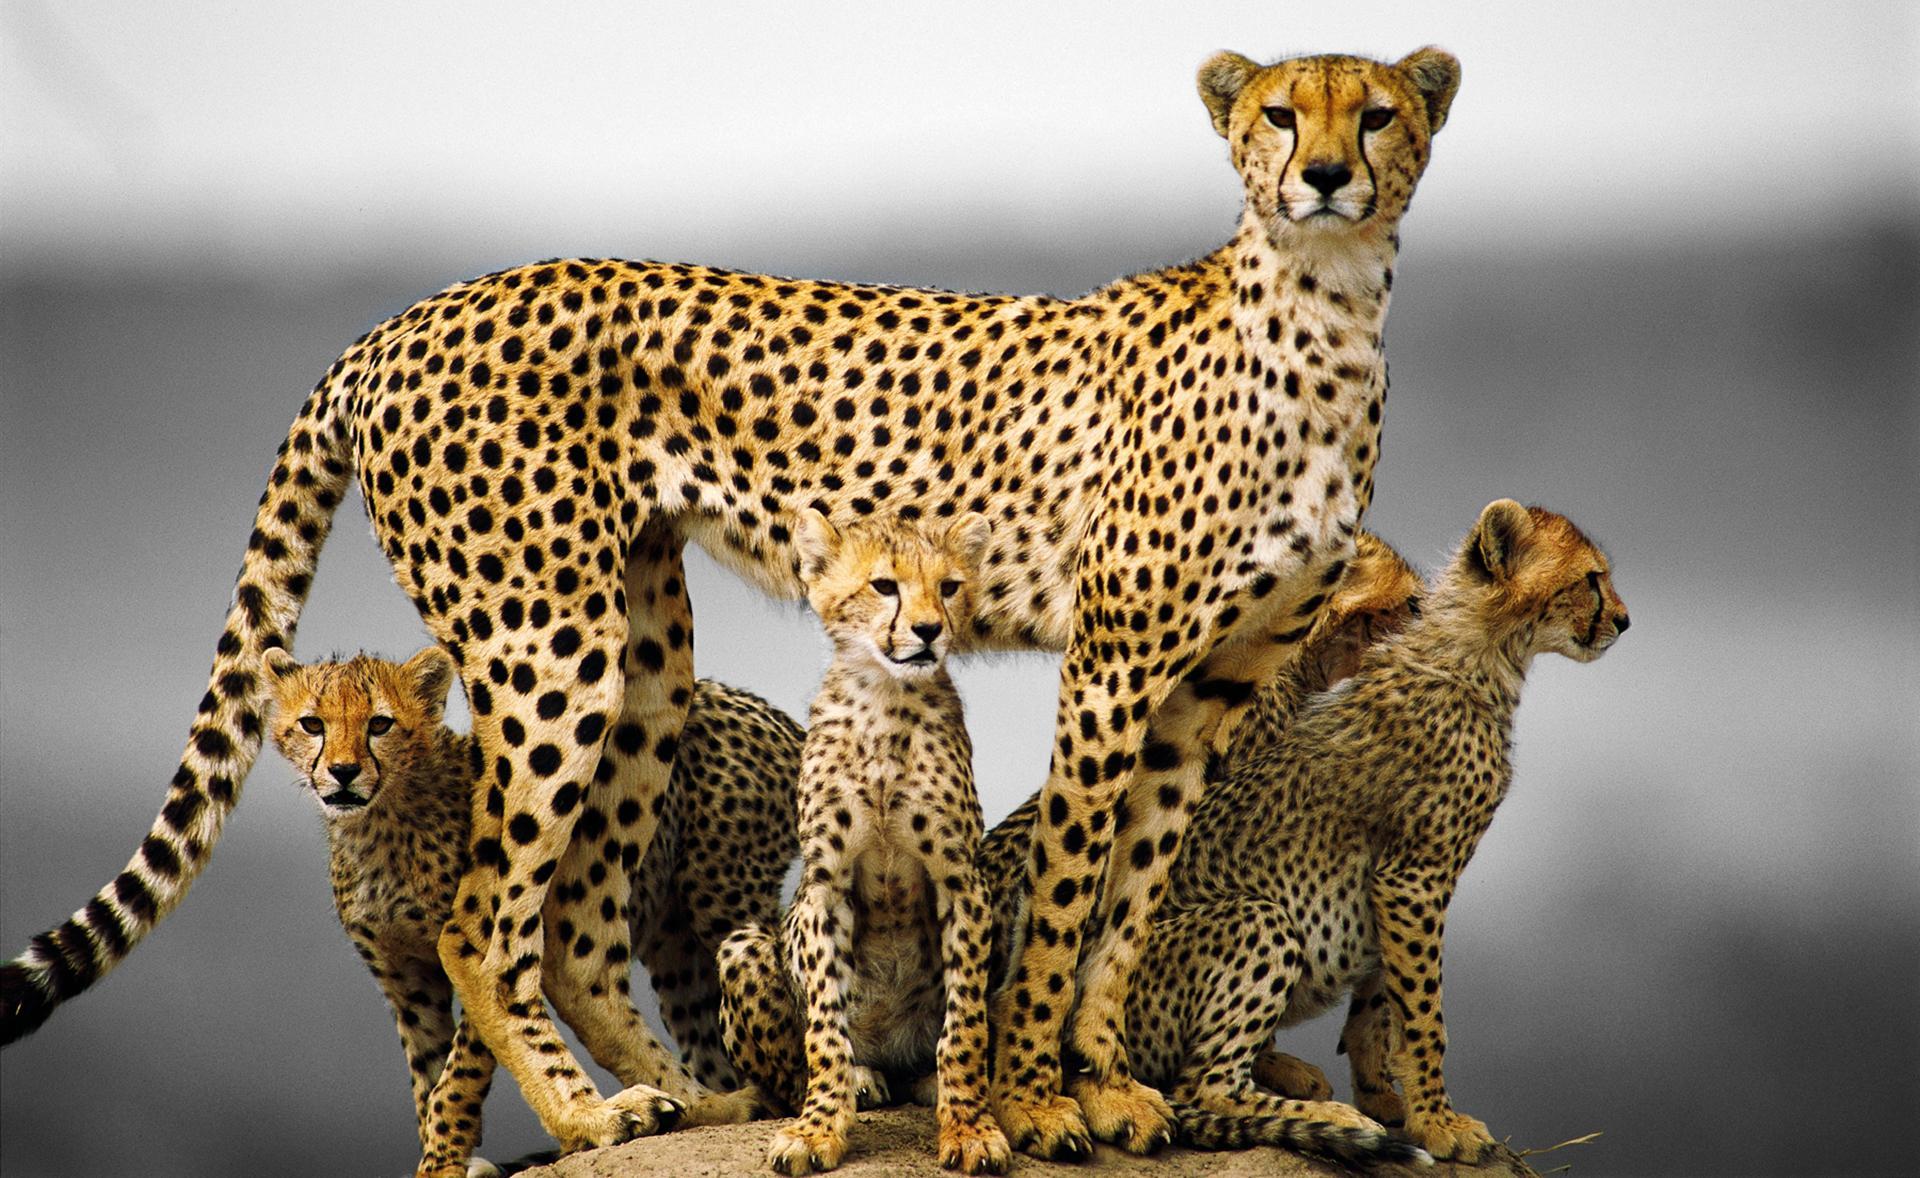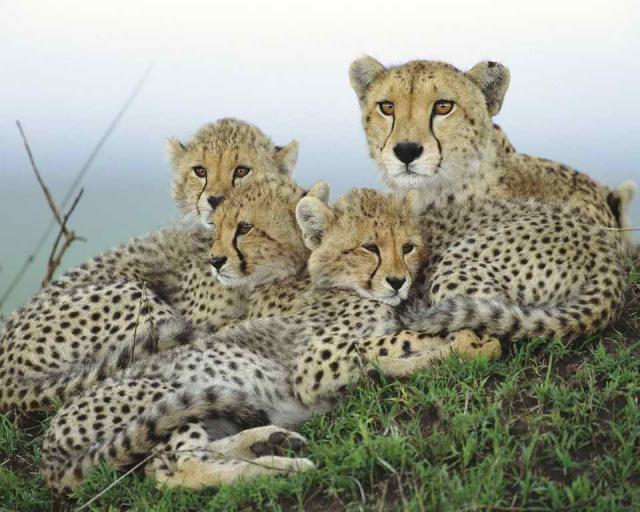The first image is the image on the left, the second image is the image on the right. Considering the images on both sides, is "An image shows a cheetah bounding across the grass with front paws off the ground." valid? Answer yes or no. No. The first image is the image on the left, the second image is the image on the right. Evaluate the accuracy of this statement regarding the images: "The left image contains at least two cheetahs.". Is it true? Answer yes or no. Yes. 